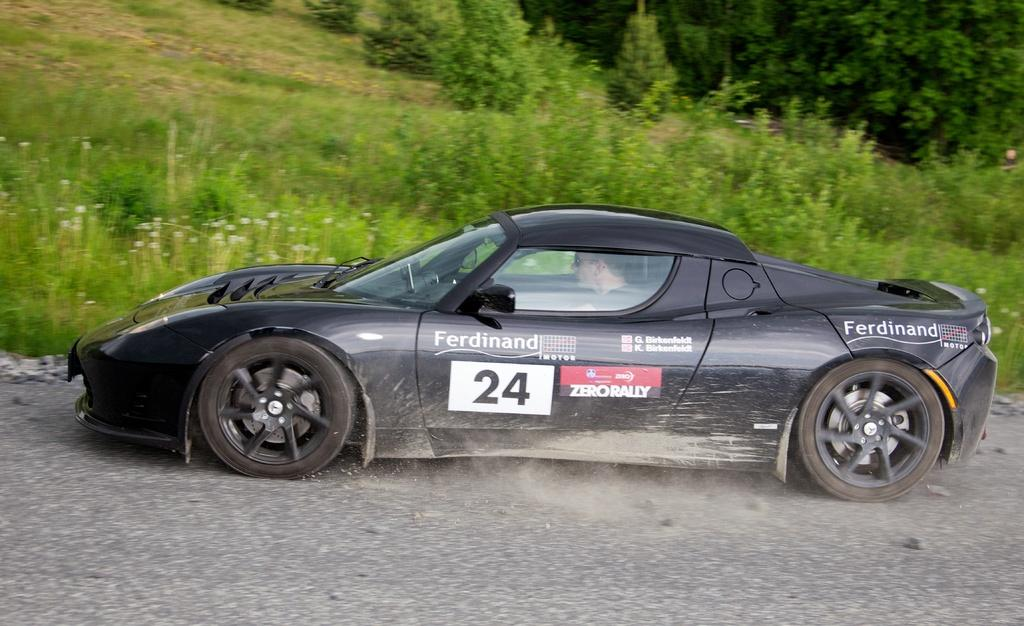Where was the image taken? The image was clicked outside. What is the person in the image doing? The person is riding a car in the image. What color is the car? The car is black in color. What type of natural environment can be seen in the background of the image? There are plants, grass, and trees visible in the background of the image. What type of page is the person reading while riding the car in the image? There is no page or book visible in the image; the person is simply riding a car. Can you tell me how many snails are crawling on the car in the image? There are no snails present in the image; the car is black and the person is riding it. 